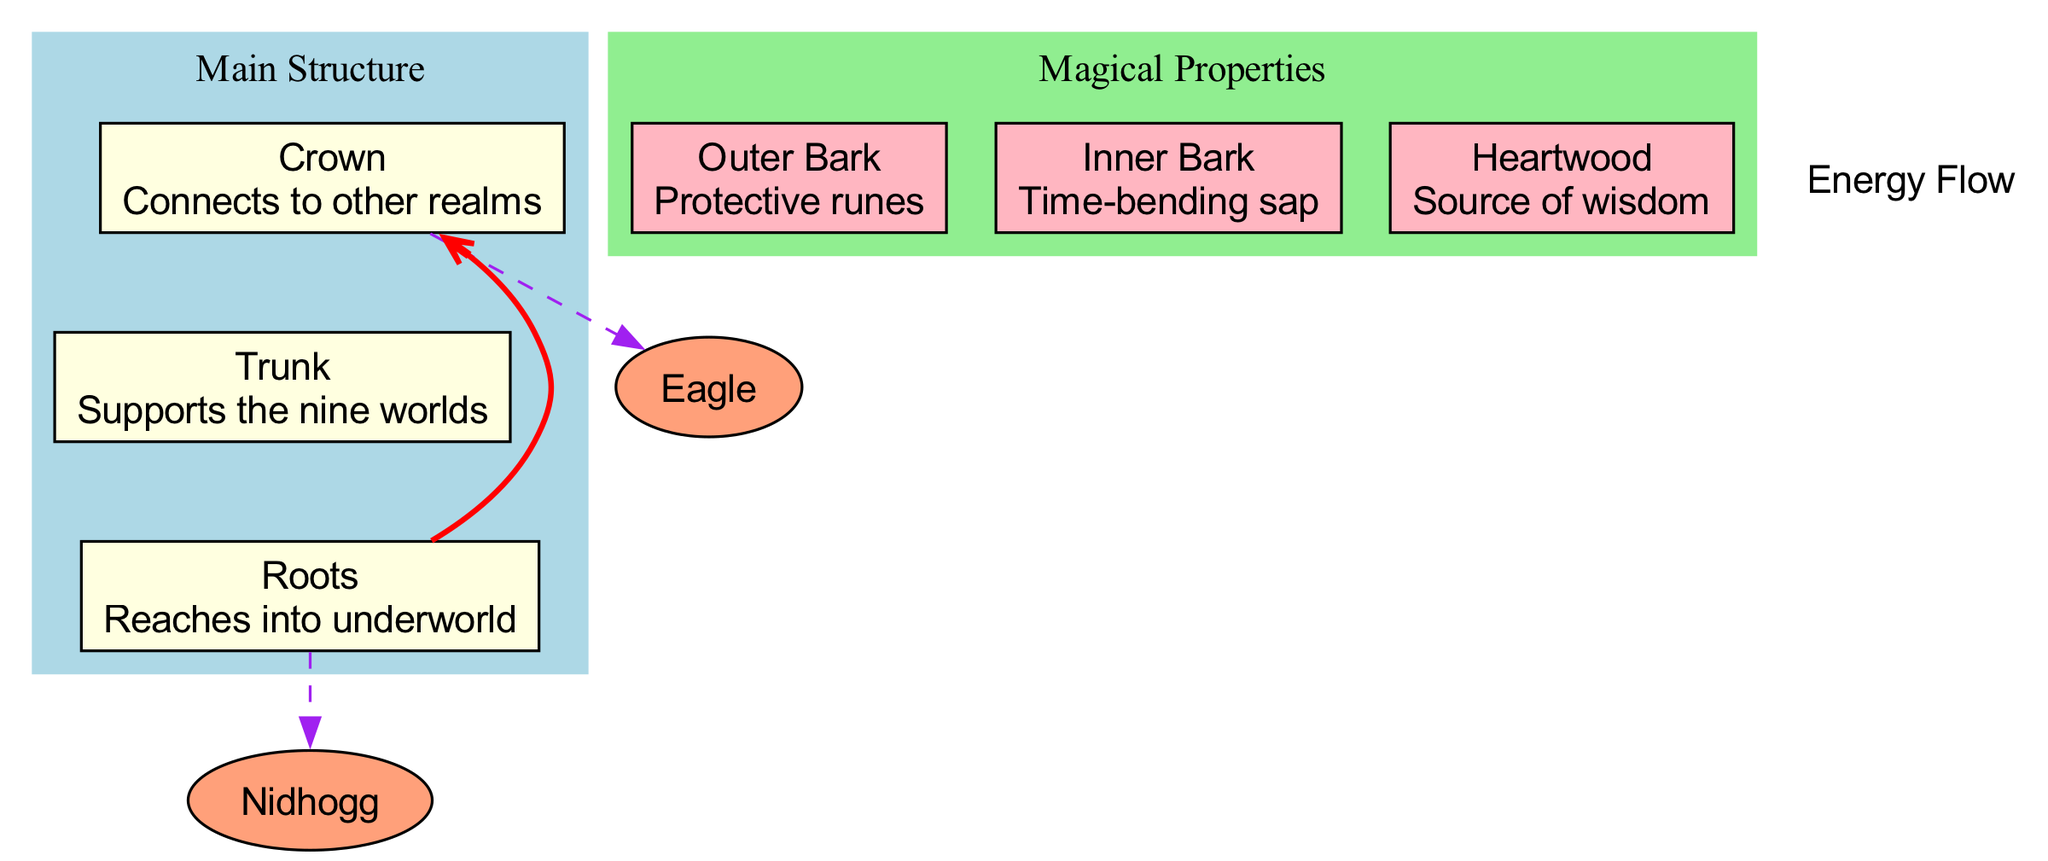What is the name of the tree? The diagram presents the tree as "Yggdrasil," which is stated at the top of the diagram as the subject of the cross-section.
Answer: Yggdrasil How many main structures does the tree have? The diagram shows three main structures: Crown, Trunk, and Roots, which are listed under the "Main Structure" label. Counting these items provides the total.
Answer: 3 What is the property of the Trunk? The diagram specifies the property of the Trunk as "Supports the nine worlds," which is directly displayed within the Trunk node.
Answer: Supports the nine worlds What magical property does the Heartwood possess? The Heartwood node indicates it has the property "Source of wisdom," as mentioned in the label for that layer in the section on Magical Properties.
Answer: Source of wisdom Which mystical being is located in the Roots? The diagram indicates that "Nidhogg" is located in the Roots section, being connected visually with a dashed line to that part of the tree.
Answer: Nidhogg What is the energy flow direction in the tree? The diagram has an edge with an arrow indicating the direction of energy flow from the Roots to the Crown, as illustrated with a red edge labeled "Energy Flow."
Answer: From roots to crown Which layer contains protective runes? The Outer Bark node states that it has the property "Protective runes," which identifies this magical feature.
Answer: Protective runes How do the Eagle and the Nidhogg relate to the tree? The Eagle is connected to the Crown and Nidhogg to the Roots, indicating their respective locations within the hierarchical structure of the tree visualized in the diagram.
Answer: Eagle - Crown, Nidhogg - Roots What color are the magical properties layers? The magical properties layers are colored light pink, as indicated in the subgraph labeled "Magical Properties" where each magical property node is shown in this color.
Answer: Light pink 